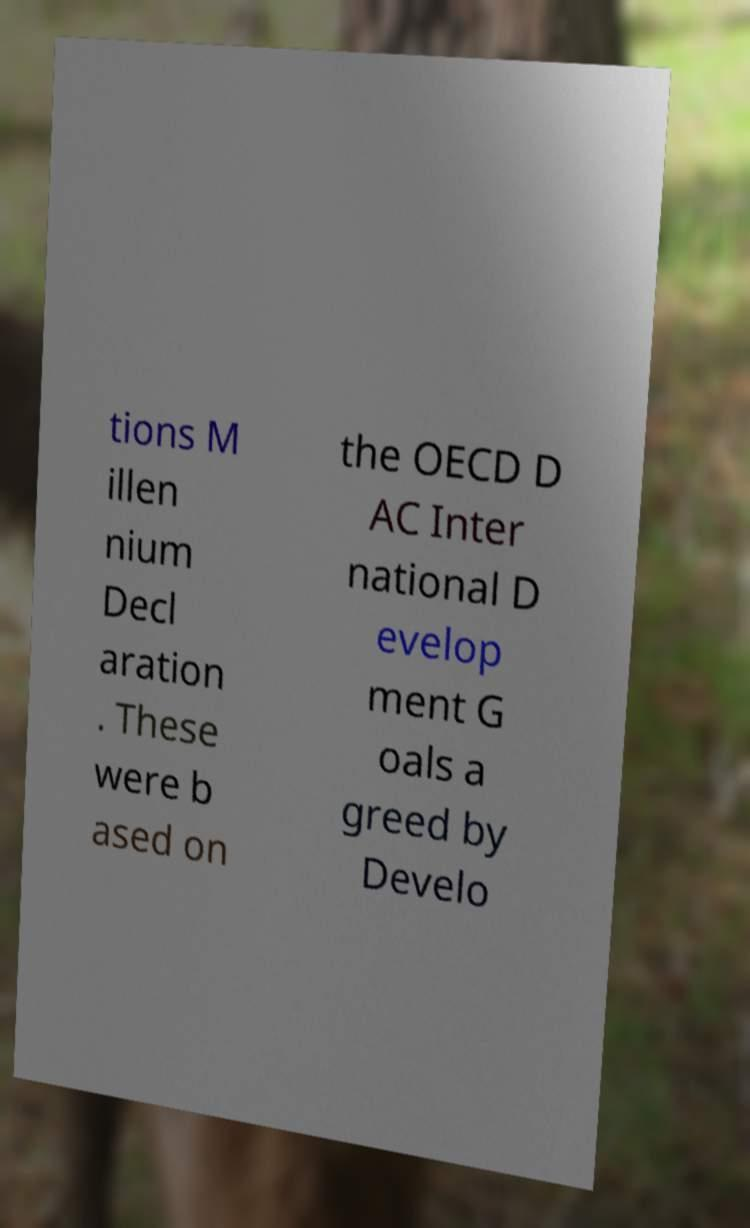Can you read and provide the text displayed in the image?This photo seems to have some interesting text. Can you extract and type it out for me? tions M illen nium Decl aration . These were b ased on the OECD D AC Inter national D evelop ment G oals a greed by Develo 